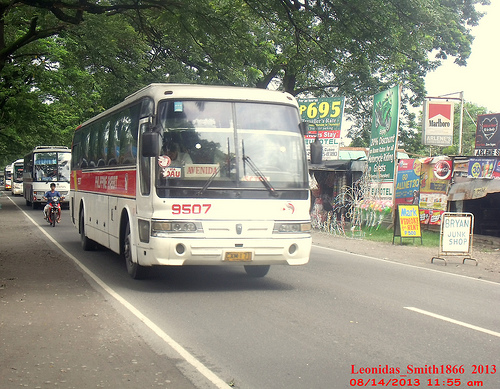Please provide a short description for this region: [0.86, 0.53, 0.96, 0.65]. A standalone sign on the roadside with multiple advertisements. 